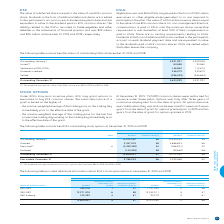From Bce's financial document, Which years does the table summarize the status of outstanding DSUs? The document shows two values: 2019 and 2018. From the document: "NUMBER OF DSUs 2019 2018 NUMBER OF DSUs 2019 2018..." Also, What is the value of a DSU at the issuance date? equal to the value of one BCE common share. The document states: "The value of a deferred share is equal to the value of one BCE common share. Dividends in the form of additional deferred shares are credited to the p..." Also, What is the weighted average fair value of the DSUs issued in 2018? According to the financial document, $55. The relevant text states: "fair value of the DSUs issued was $59 in 2019 and $55 in 2018...." Additionally, In which year is the amount of Issued DSUs larger? According to the financial document, 2018. The relevant text states: "NUMBER OF DSUs 2019 2018..." Also, can you calculate: What is the fair value of the DSUs issued in 2019? Based on the calculation: 84,588*$59, the result is 4990692. This is based on the information: "Issued (1) 84,588 94,580 ighted average fair value of the DSUs issued was $59 in 2019 and $55 in 2018...." The key data points involved are: 59, 84,588. Also, can you calculate: What is the average value of the weighted average fair value of the DSUs issued in 2018 and 2019? To answer this question, I need to perform calculations using the financial data. The calculation is: ($59+$55)/2, which equals 57. This is based on the information: "ighted average fair value of the DSUs issued was $59 in 2019 and $55 in 2018. air value of the DSUs issued was $59 in 2019 and $55 in 2018...." The key data points involved are: 55, 59. 